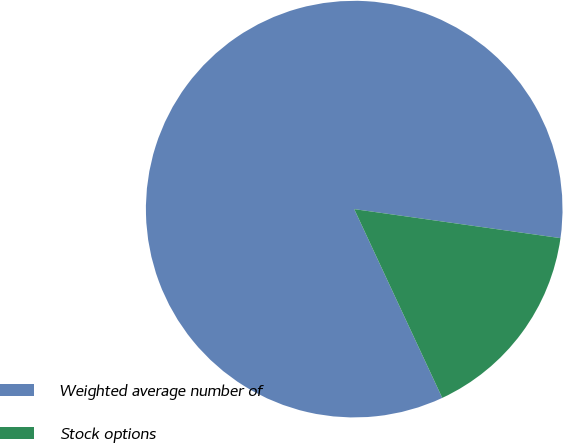<chart> <loc_0><loc_0><loc_500><loc_500><pie_chart><fcel>Weighted average number of<fcel>Stock options<nl><fcel>84.17%<fcel>15.83%<nl></chart> 